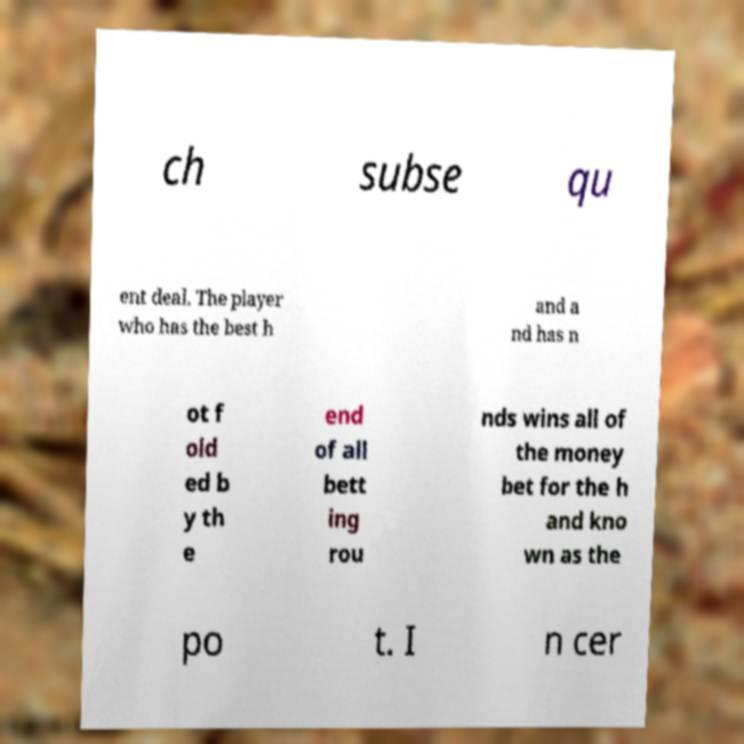Can you accurately transcribe the text from the provided image for me? ch subse qu ent deal. The player who has the best h and a nd has n ot f old ed b y th e end of all bett ing rou nds wins all of the money bet for the h and kno wn as the po t. I n cer 